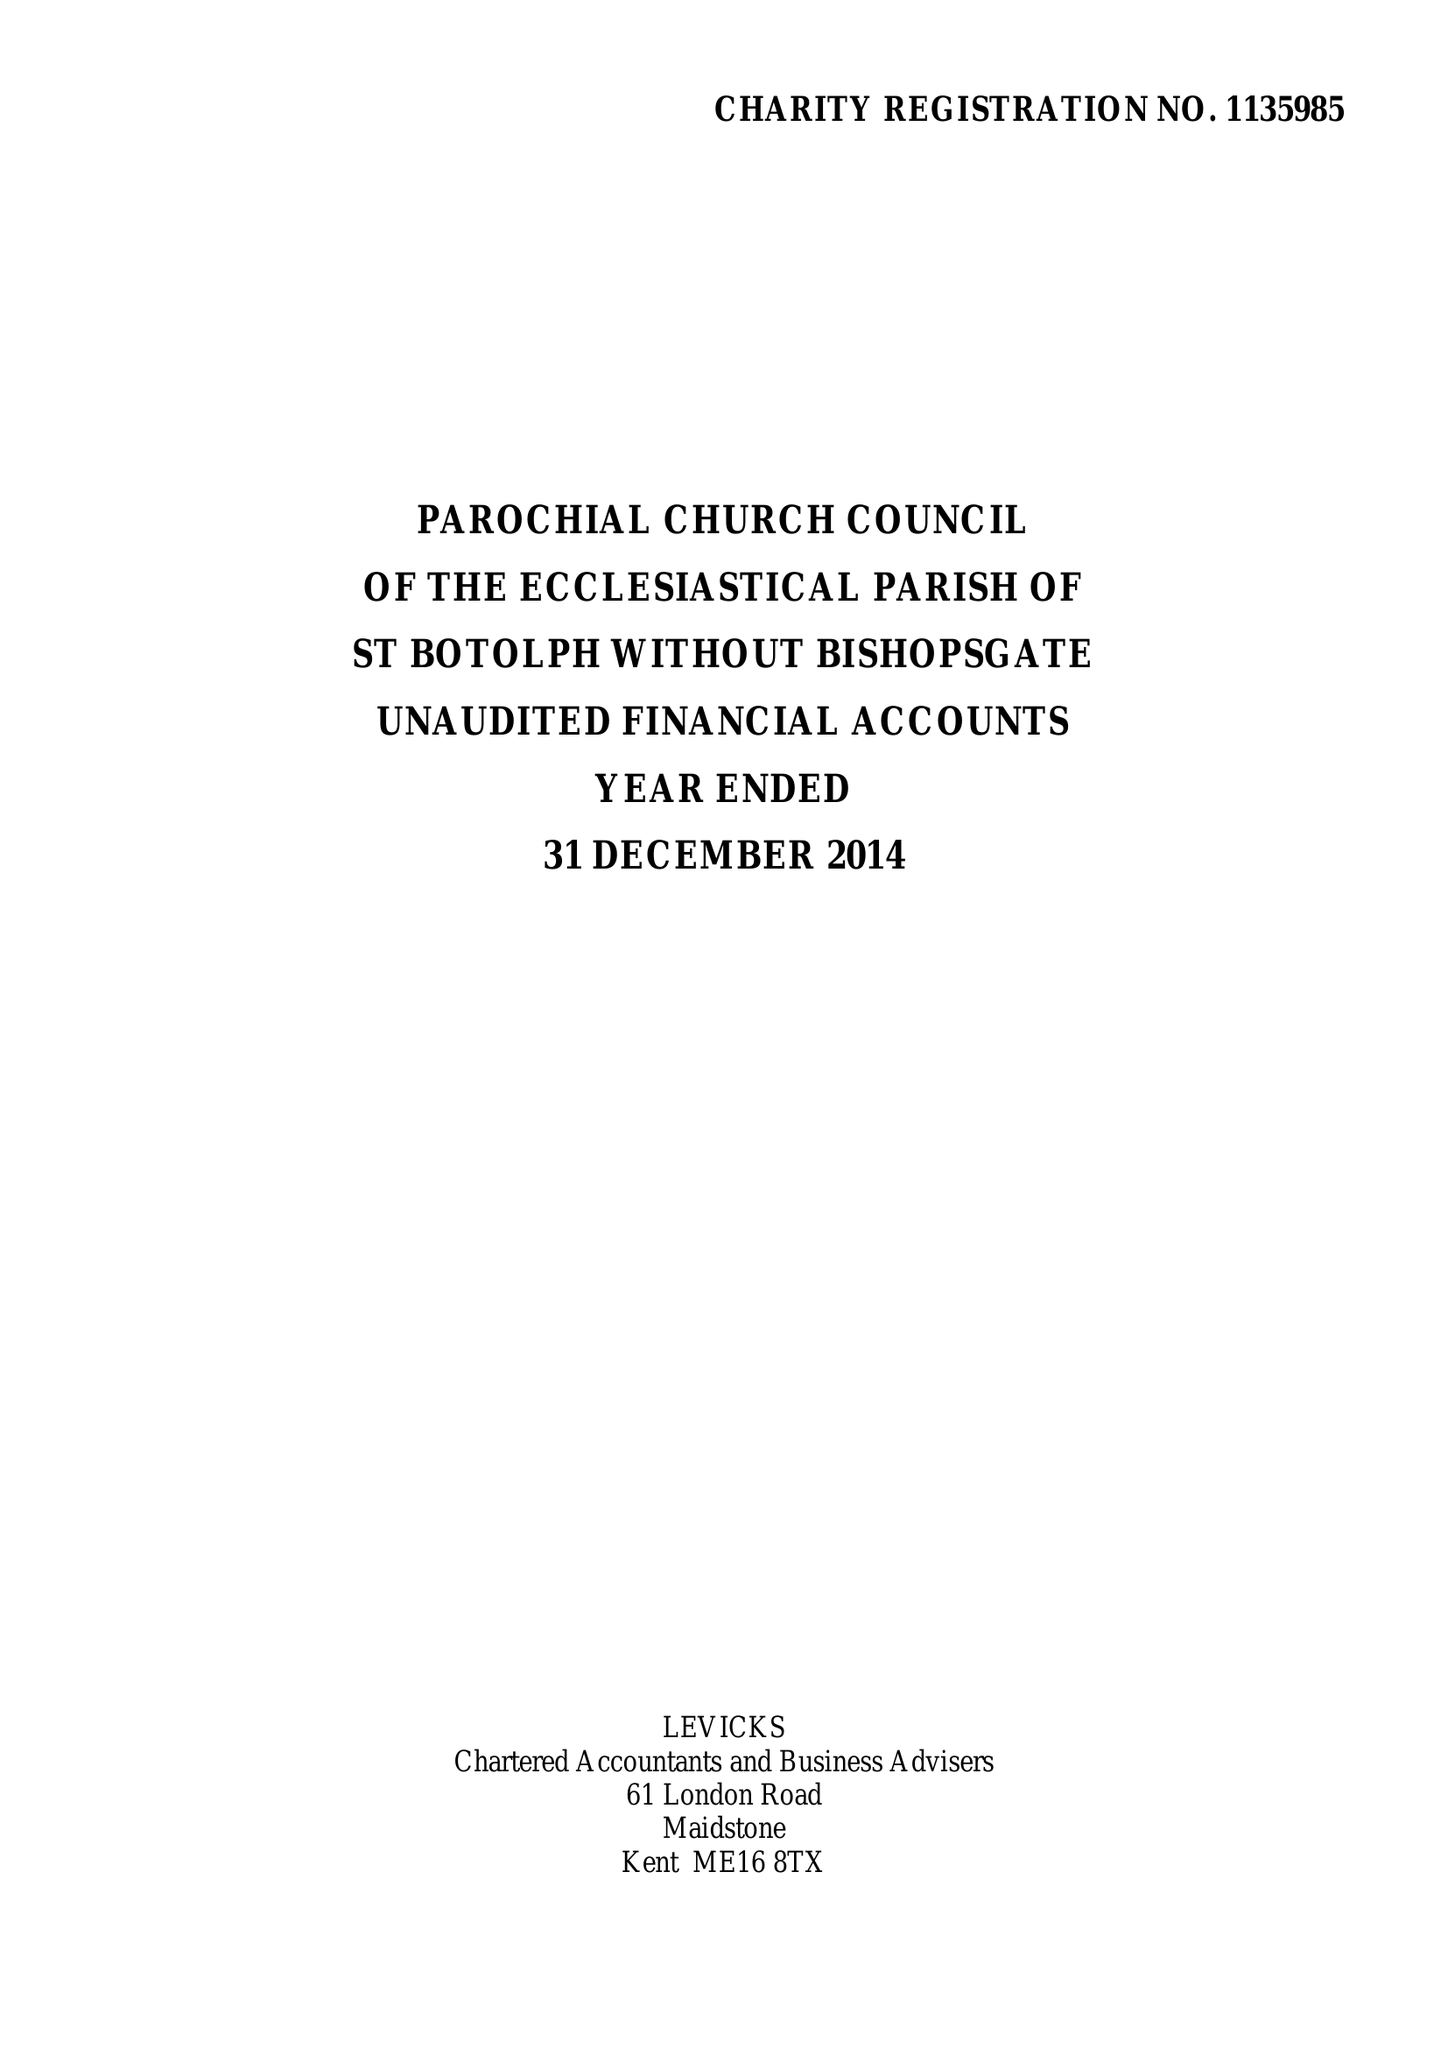What is the value for the address__street_line?
Answer the question using a single word or phrase. BISHOPSGATE 